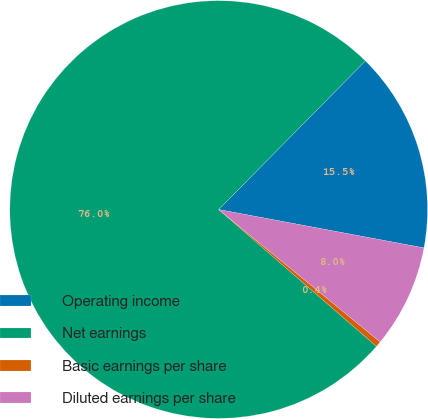<chart> <loc_0><loc_0><loc_500><loc_500><pie_chart><fcel>Operating income<fcel>Net earnings<fcel>Basic earnings per share<fcel>Diluted earnings per share<nl><fcel>15.55%<fcel>76.02%<fcel>0.44%<fcel>7.99%<nl></chart> 